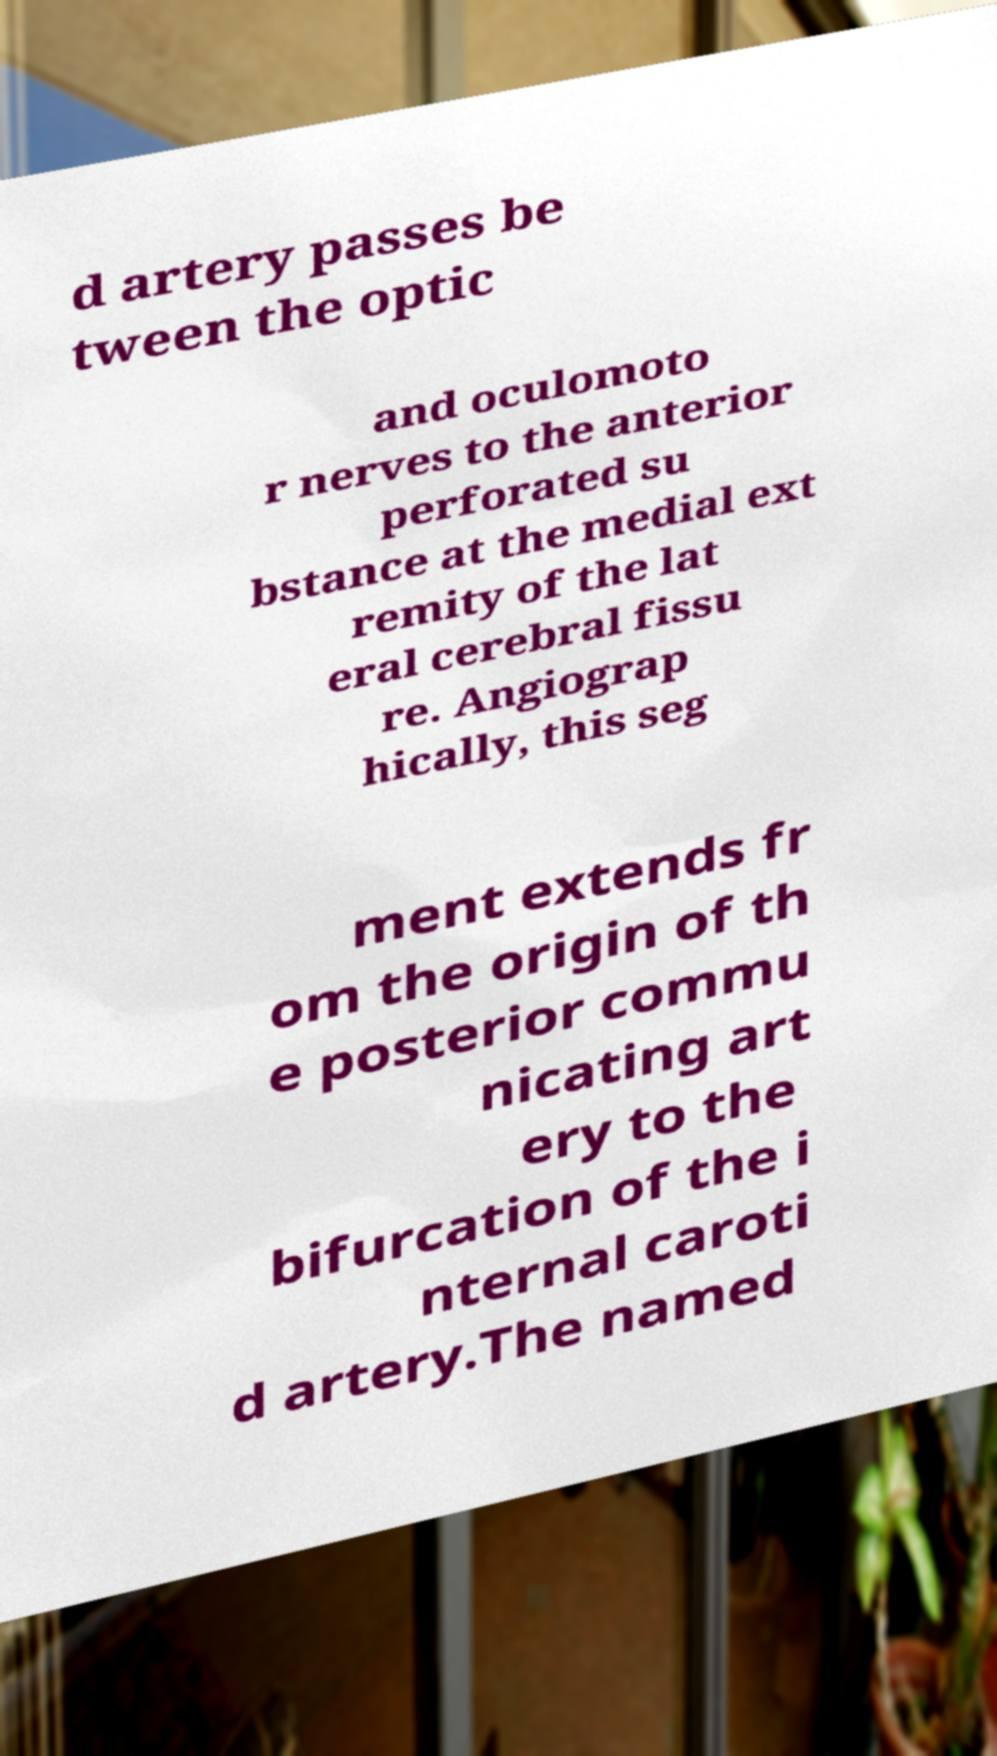Please identify and transcribe the text found in this image. d artery passes be tween the optic and oculomoto r nerves to the anterior perforated su bstance at the medial ext remity of the lat eral cerebral fissu re. Angiograp hically, this seg ment extends fr om the origin of th e posterior commu nicating art ery to the bifurcation of the i nternal caroti d artery.The named 